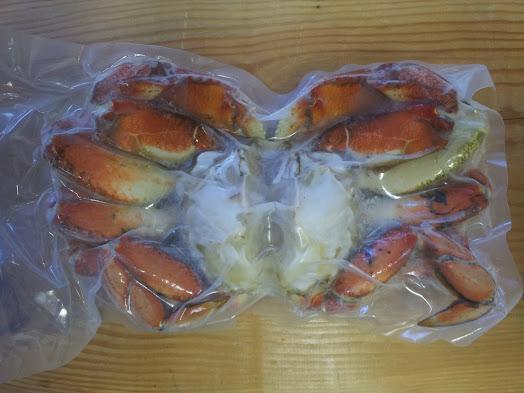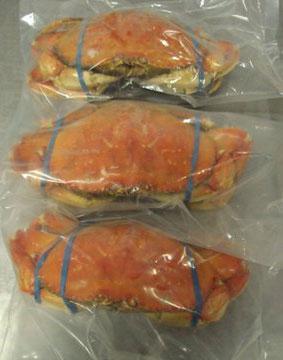The first image is the image on the left, the second image is the image on the right. Considering the images on both sides, is "A ruler depicts the size of a crab." valid? Answer yes or no. No. The first image is the image on the left, the second image is the image on the right. Evaluate the accuracy of this statement regarding the images: "The left image shows one clear plastic wrapper surrounding red-orange crab claws, and the right image shows multiple individually plastic wrapped crabs.". Is it true? Answer yes or no. Yes. 